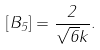<formula> <loc_0><loc_0><loc_500><loc_500>\left [ B _ { 5 } \right ] = \frac { 2 } { \sqrt { 6 } k } .</formula> 